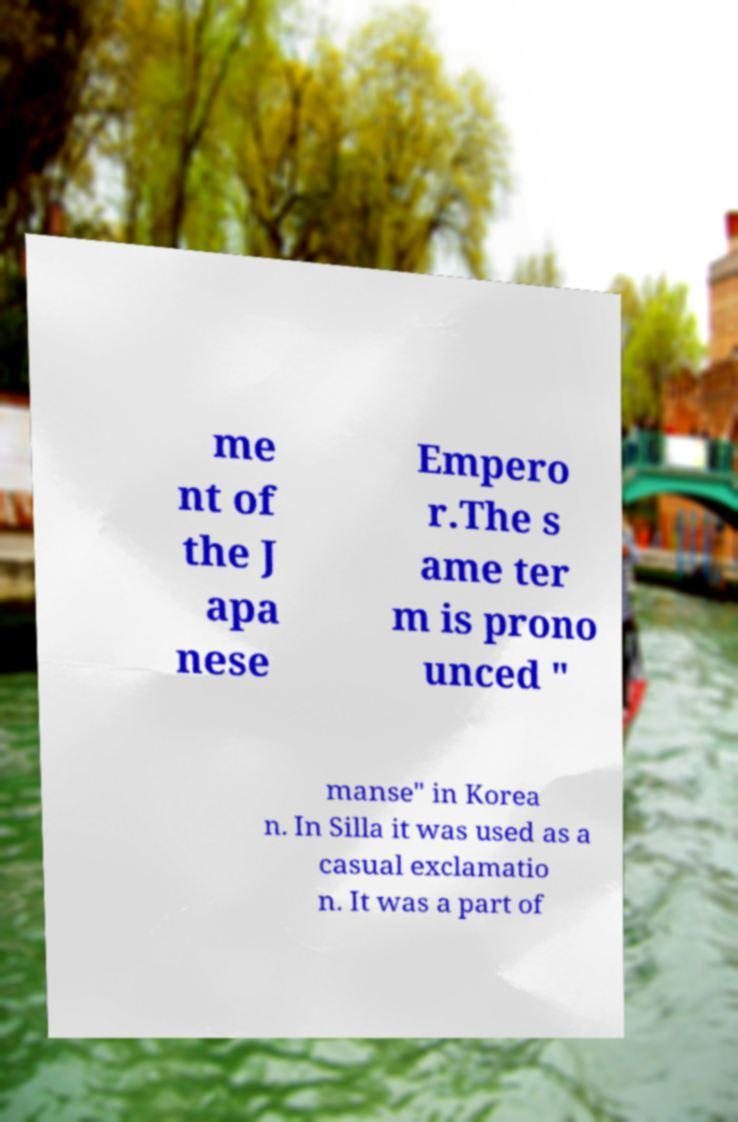Can you accurately transcribe the text from the provided image for me? me nt of the J apa nese Empero r.The s ame ter m is prono unced " manse" in Korea n. In Silla it was used as a casual exclamatio n. It was a part of 